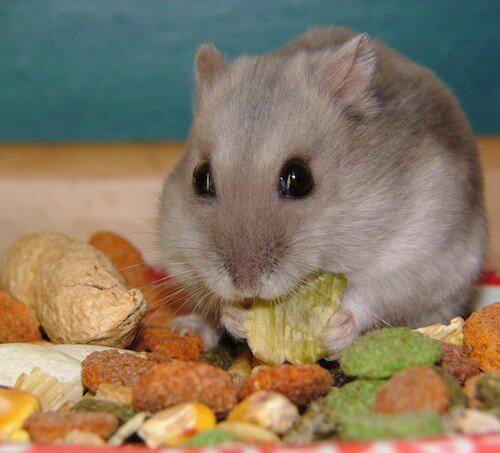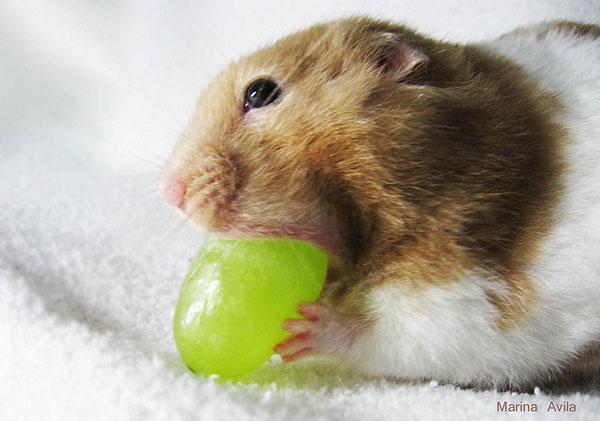The first image is the image on the left, the second image is the image on the right. Analyze the images presented: Is the assertion "A rodent is busy munching on a piece of broccoli." valid? Answer yes or no. No. The first image is the image on the left, the second image is the image on the right. For the images displayed, is the sentence "A hamster is eating broccoli on a white floor" factually correct? Answer yes or no. No. 